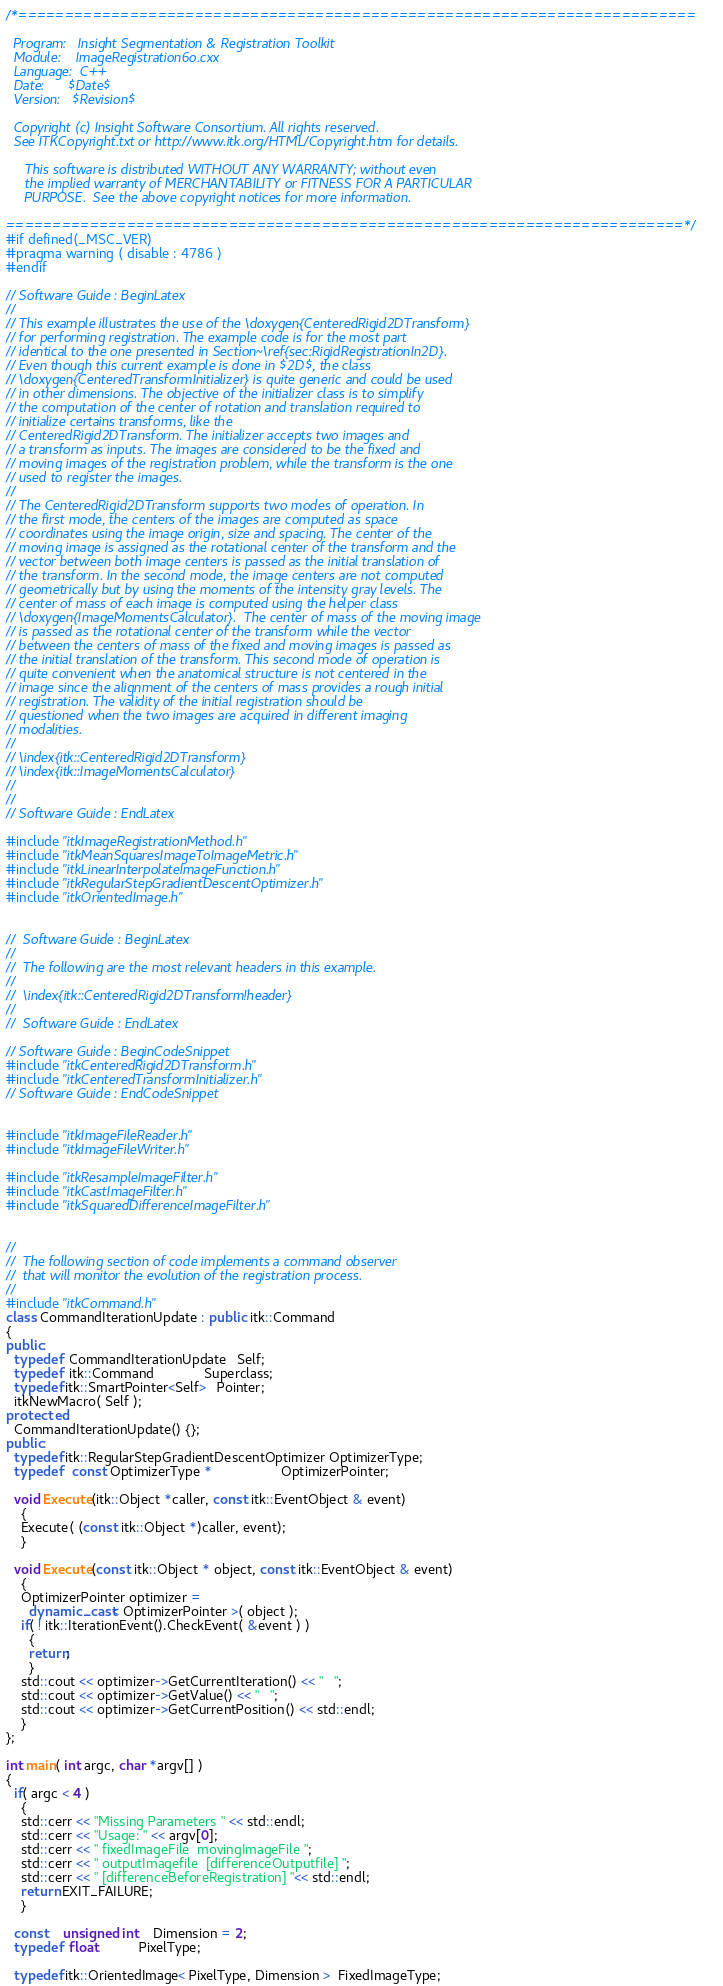<code> <loc_0><loc_0><loc_500><loc_500><_C++_>/*=========================================================================

  Program:   Insight Segmentation & Registration Toolkit
  Module:    ImageRegistration6o.cxx
  Language:  C++
  Date:      $Date$
  Version:   $Revision$

  Copyright (c) Insight Software Consortium. All rights reserved.
  See ITKCopyright.txt or http://www.itk.org/HTML/Copyright.htm for details.

     This software is distributed WITHOUT ANY WARRANTY; without even 
     the implied warranty of MERCHANTABILITY or FITNESS FOR A PARTICULAR 
     PURPOSE.  See the above copyright notices for more information.

=========================================================================*/
#if defined(_MSC_VER)
#pragma warning ( disable : 4786 )
#endif

// Software Guide : BeginLatex
//
// This example illustrates the use of the \doxygen{CenteredRigid2DTransform}
// for performing registration. The example code is for the most part
// identical to the one presented in Section~\ref{sec:RigidRegistrationIn2D}.
// Even though this current example is done in $2D$, the class
// \doxygen{CenteredTransformInitializer} is quite generic and could be used
// in other dimensions. The objective of the initializer class is to simplify
// the computation of the center of rotation and translation required to
// initialize certains transforms, like the
// CenteredRigid2DTransform. The initializer accepts two images and
// a transform as inputs. The images are considered to be the fixed and
// moving images of the registration problem, while the transform is the one
// used to register the images.
//
// The CenteredRigid2DTransform supports two modes of operation. In
// the first mode, the centers of the images are computed as space
// coordinates using the image origin, size and spacing. The center of the
// moving image is assigned as the rotational center of the transform and the
// vector between both image centers is passed as the initial translation of
// the transform. In the second mode, the image centers are not computed
// geometrically but by using the moments of the intensity gray levels. The
// center of mass of each image is computed using the helper class
// \doxygen{ImageMomentsCalculator}.  The center of mass of the moving image
// is passed as the rotational center of the transform while the vector
// between the centers of mass of the fixed and moving images is passed as
// the initial translation of the transform. This second mode of operation is
// quite convenient when the anatomical structure is not centered in the
// image since the alignment of the centers of mass provides a rough initial
// registration. The validity of the initial registration should be
// questioned when the two images are acquired in different imaging
// modalities.
//
// \index{itk::CenteredRigid2DTransform}
// \index{itk::ImageMomentsCalculator}
//
//
// Software Guide : EndLatex 

#include "itkImageRegistrationMethod.h"
#include "itkMeanSquaresImageToImageMetric.h"
#include "itkLinearInterpolateImageFunction.h"
#include "itkRegularStepGradientDescentOptimizer.h"
#include "itkOrientedImage.h"


//  Software Guide : BeginLatex
//  
//  The following are the most relevant headers in this example.
//
//  \index{itk::CenteredRigid2DTransform!header}
// 
//  Software Guide : EndLatex 

// Software Guide : BeginCodeSnippet
#include "itkCenteredRigid2DTransform.h"
#include "itkCenteredTransformInitializer.h"
// Software Guide : EndCodeSnippet


#include "itkImageFileReader.h"
#include "itkImageFileWriter.h"

#include "itkResampleImageFilter.h"
#include "itkCastImageFilter.h"
#include "itkSquaredDifferenceImageFilter.h"


//
//  The following section of code implements a command observer
//  that will monitor the evolution of the registration process.
//
#include "itkCommand.h"
class CommandIterationUpdate : public itk::Command 
{
public:
  typedef  CommandIterationUpdate   Self;
  typedef  itk::Command             Superclass;
  typedef itk::SmartPointer<Self>   Pointer;
  itkNewMacro( Self );
protected:
  CommandIterationUpdate() {};
public:
  typedef itk::RegularStepGradientDescentOptimizer OptimizerType;
  typedef   const OptimizerType *                  OptimizerPointer;

  void Execute(itk::Object *caller, const itk::EventObject & event)
    {
    Execute( (const itk::Object *)caller, event);
    }

  void Execute(const itk::Object * object, const itk::EventObject & event)
    {
    OptimizerPointer optimizer = 
      dynamic_cast< OptimizerPointer >( object );
    if( ! itk::IterationEvent().CheckEvent( &event ) )
      {
      return;
      }
    std::cout << optimizer->GetCurrentIteration() << "   ";
    std::cout << optimizer->GetValue() << "   ";
    std::cout << optimizer->GetCurrentPosition() << std::endl;
    }
};

int main( int argc, char *argv[] )
{
  if( argc < 4 )
    {
    std::cerr << "Missing Parameters " << std::endl;
    std::cerr << "Usage: " << argv[0];
    std::cerr << " fixedImageFile  movingImageFile ";
    std::cerr << " outputImagefile  [differenceOutputfile] ";
    std::cerr << " [differenceBeforeRegistration] "<< std::endl;
    return EXIT_FAILURE;
    }
  
  const    unsigned int    Dimension = 2;
  typedef  float           PixelType;

  typedef itk::OrientedImage< PixelType, Dimension >  FixedImageType;</code> 